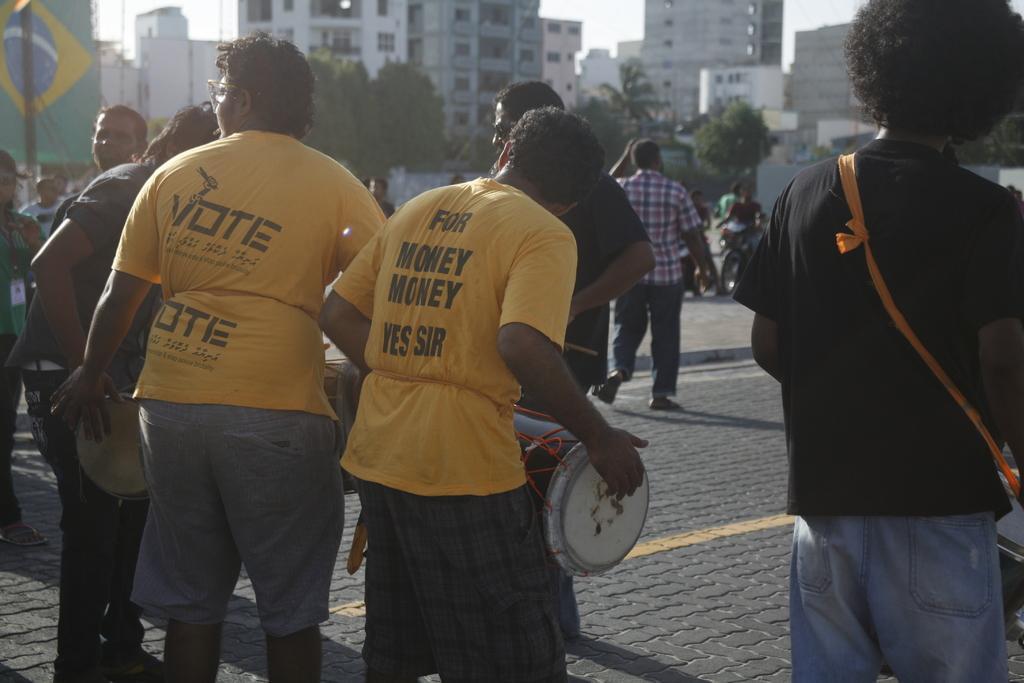Describe this image in one or two sentences. In the middle of the image few people are standing and holding some musical instruments. Behind them few people are walking and riding motorcycles and there are some trees and buildings. 